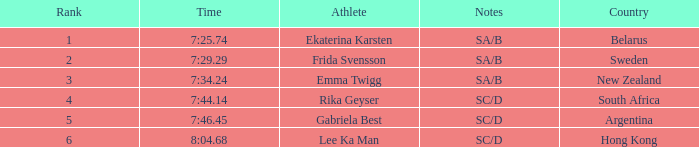What country is the athlete ekaterina karsten from with a rank less than 4? Belarus. 